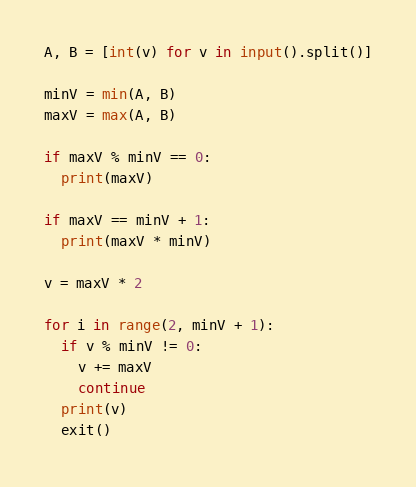Convert code to text. <code><loc_0><loc_0><loc_500><loc_500><_Python_>A, B = [int(v) for v in input().split()]

minV = min(A, B)
maxV = max(A, B)

if maxV % minV == 0:
  print(maxV)

if maxV == minV + 1:
  print(maxV * minV)

v = maxV * 2

for i in range(2, minV + 1):
  if v % minV != 0:
    v += maxV
    continue
  print(v)
  exit()
</code> 